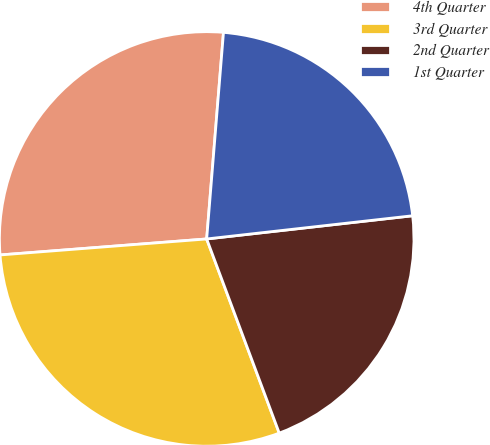<chart> <loc_0><loc_0><loc_500><loc_500><pie_chart><fcel>4th Quarter<fcel>3rd Quarter<fcel>2nd Quarter<fcel>1st Quarter<nl><fcel>27.52%<fcel>29.46%<fcel>21.09%<fcel>21.92%<nl></chart> 